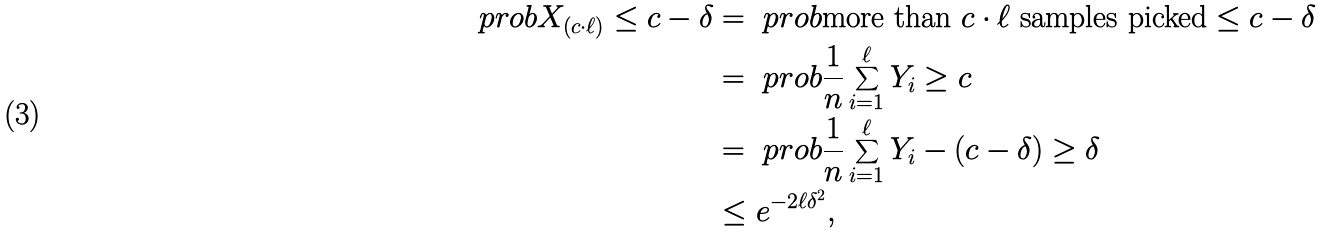Convert formula to latex. <formula><loc_0><loc_0><loc_500><loc_500>\ p r o b { X _ { ( c \cdot \ell ) } \leq c - \delta } & = \ p r o b { \text {more than } c \cdot \ell \text { samples picked} \leq c - \delta } \\ & = \ p r o b { \frac { 1 } { n } \sum _ { i = 1 } ^ { \ell } Y _ { i } \geq c } \\ & = \ p r o b { \frac { 1 } { n } \sum _ { i = 1 } ^ { \ell } Y _ { i } - ( c - \delta ) \geq \delta } \\ & \leq e ^ { - 2 \ell \delta ^ { 2 } } ,</formula> 